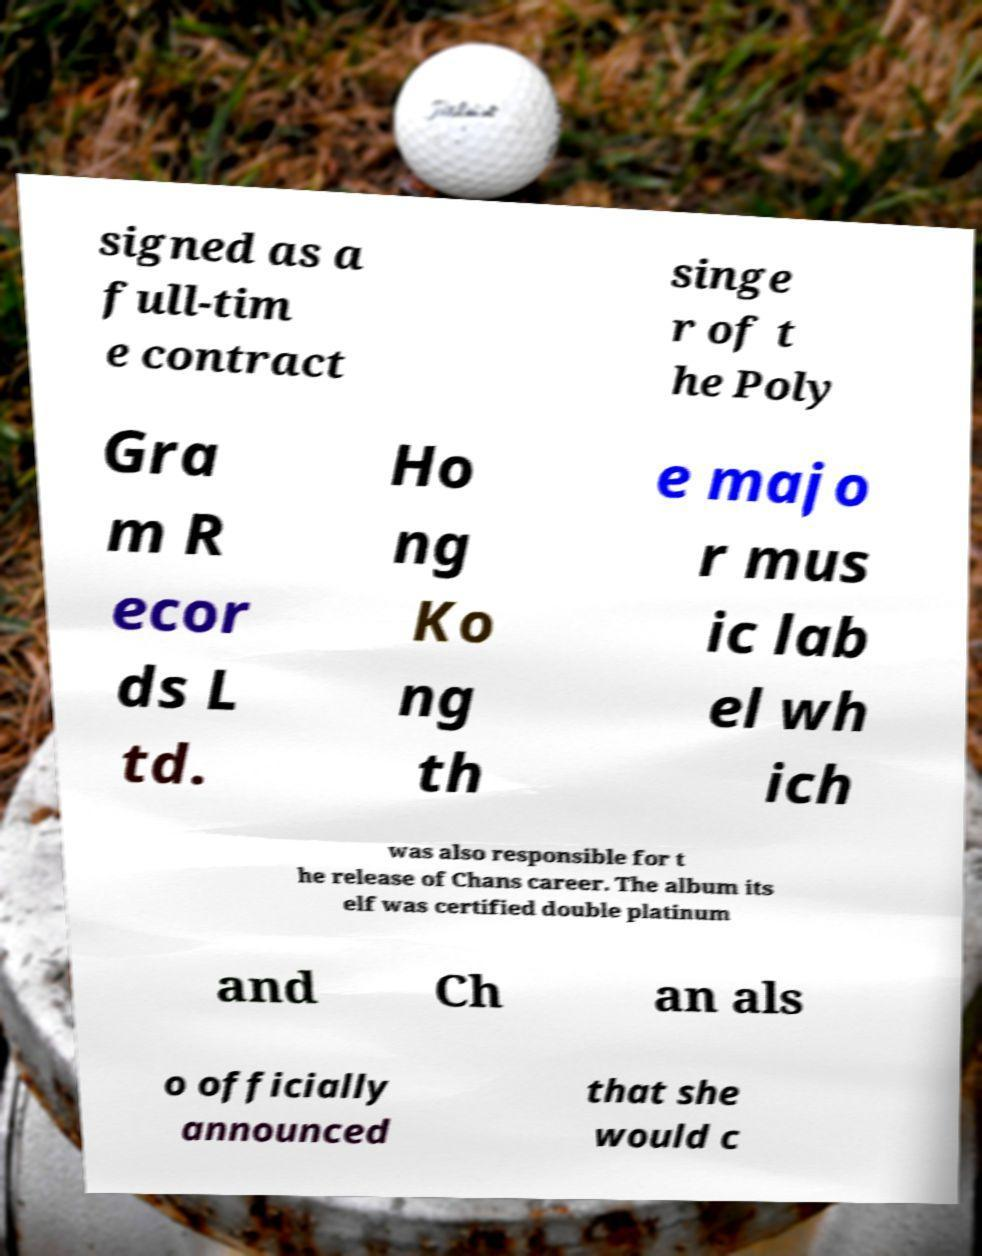Please identify and transcribe the text found in this image. signed as a full-tim e contract singe r of t he Poly Gra m R ecor ds L td. Ho ng Ko ng th e majo r mus ic lab el wh ich was also responsible for t he release of Chans career. The album its elf was certified double platinum and Ch an als o officially announced that she would c 